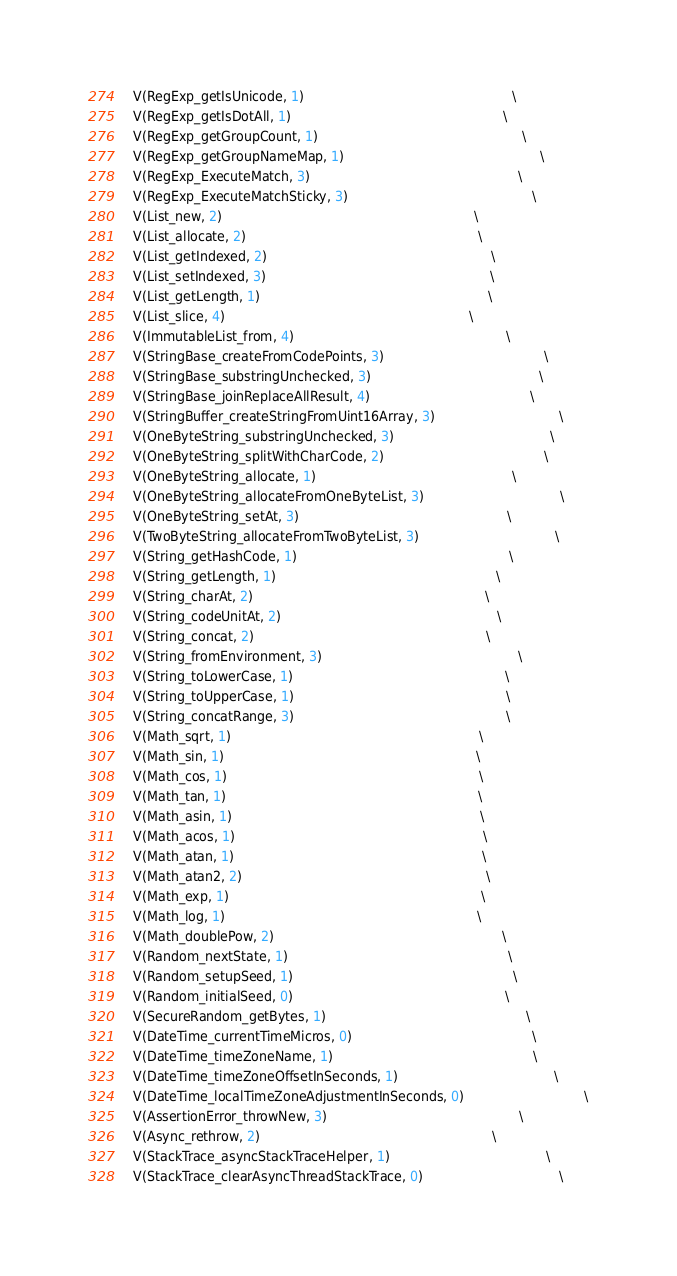Convert code to text. <code><loc_0><loc_0><loc_500><loc_500><_C_>  V(RegExp_getIsUnicode, 1)                                                    \
  V(RegExp_getIsDotAll, 1)                                                     \
  V(RegExp_getGroupCount, 1)                                                   \
  V(RegExp_getGroupNameMap, 1)                                                 \
  V(RegExp_ExecuteMatch, 3)                                                    \
  V(RegExp_ExecuteMatchSticky, 3)                                              \
  V(List_new, 2)                                                               \
  V(List_allocate, 2)                                                          \
  V(List_getIndexed, 2)                                                        \
  V(List_setIndexed, 3)                                                        \
  V(List_getLength, 1)                                                         \
  V(List_slice, 4)                                                             \
  V(ImmutableList_from, 4)                                                     \
  V(StringBase_createFromCodePoints, 3)                                        \
  V(StringBase_substringUnchecked, 3)                                          \
  V(StringBase_joinReplaceAllResult, 4)                                        \
  V(StringBuffer_createStringFromUint16Array, 3)                               \
  V(OneByteString_substringUnchecked, 3)                                       \
  V(OneByteString_splitWithCharCode, 2)                                        \
  V(OneByteString_allocate, 1)                                                 \
  V(OneByteString_allocateFromOneByteList, 3)                                  \
  V(OneByteString_setAt, 3)                                                    \
  V(TwoByteString_allocateFromTwoByteList, 3)                                  \
  V(String_getHashCode, 1)                                                     \
  V(String_getLength, 1)                                                       \
  V(String_charAt, 2)                                                          \
  V(String_codeUnitAt, 2)                                                      \
  V(String_concat, 2)                                                          \
  V(String_fromEnvironment, 3)                                                 \
  V(String_toLowerCase, 1)                                                     \
  V(String_toUpperCase, 1)                                                     \
  V(String_concatRange, 3)                                                     \
  V(Math_sqrt, 1)                                                              \
  V(Math_sin, 1)                                                               \
  V(Math_cos, 1)                                                               \
  V(Math_tan, 1)                                                               \
  V(Math_asin, 1)                                                              \
  V(Math_acos, 1)                                                              \
  V(Math_atan, 1)                                                              \
  V(Math_atan2, 2)                                                             \
  V(Math_exp, 1)                                                               \
  V(Math_log, 1)                                                               \
  V(Math_doublePow, 2)                                                         \
  V(Random_nextState, 1)                                                       \
  V(Random_setupSeed, 1)                                                       \
  V(Random_initialSeed, 0)                                                     \
  V(SecureRandom_getBytes, 1)                                                  \
  V(DateTime_currentTimeMicros, 0)                                             \
  V(DateTime_timeZoneName, 1)                                                  \
  V(DateTime_timeZoneOffsetInSeconds, 1)                                       \
  V(DateTime_localTimeZoneAdjustmentInSeconds, 0)                              \
  V(AssertionError_throwNew, 3)                                                \
  V(Async_rethrow, 2)                                                          \
  V(StackTrace_asyncStackTraceHelper, 1)                                       \
  V(StackTrace_clearAsyncThreadStackTrace, 0)                                  \</code> 